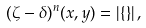<formula> <loc_0><loc_0><loc_500><loc_500>( \zeta - \delta ) ^ { n } ( x , y ) = | \{ \} | \, ,</formula> 